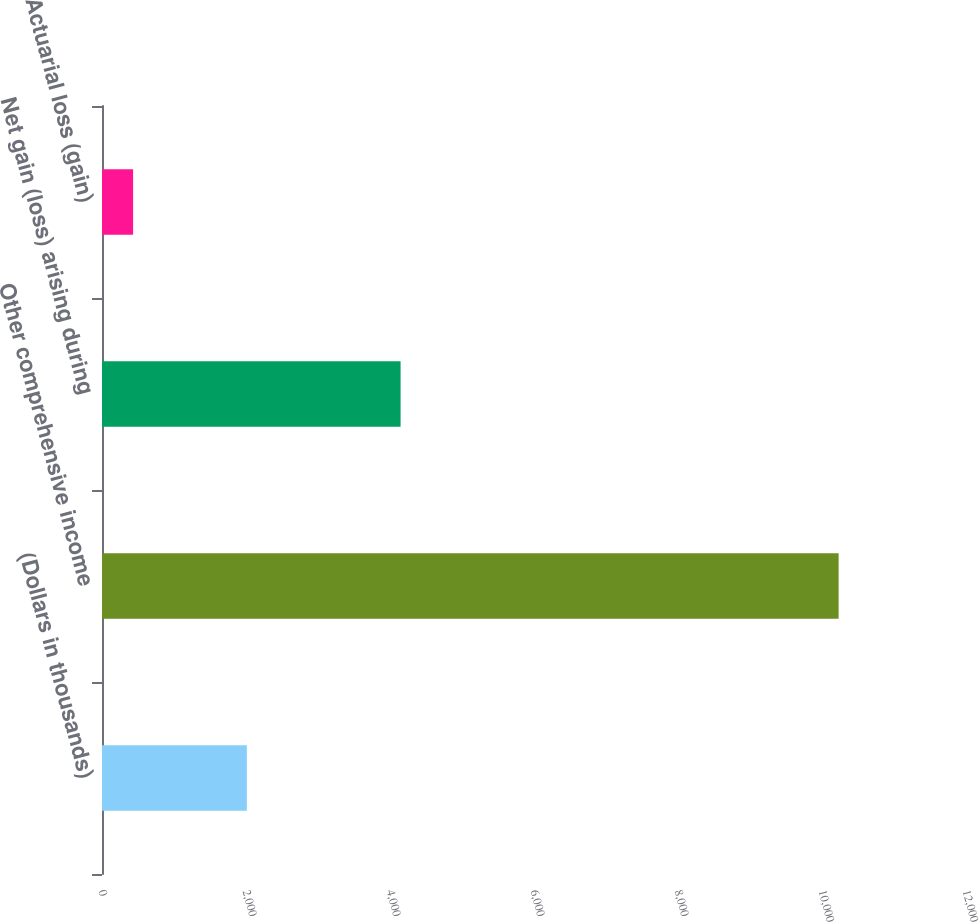<chart> <loc_0><loc_0><loc_500><loc_500><bar_chart><fcel>(Dollars in thousands)<fcel>Other comprehensive income<fcel>Net gain (loss) arising during<fcel>Actuarial loss (gain)<nl><fcel>2012<fcel>10231<fcel>4147<fcel>432<nl></chart> 